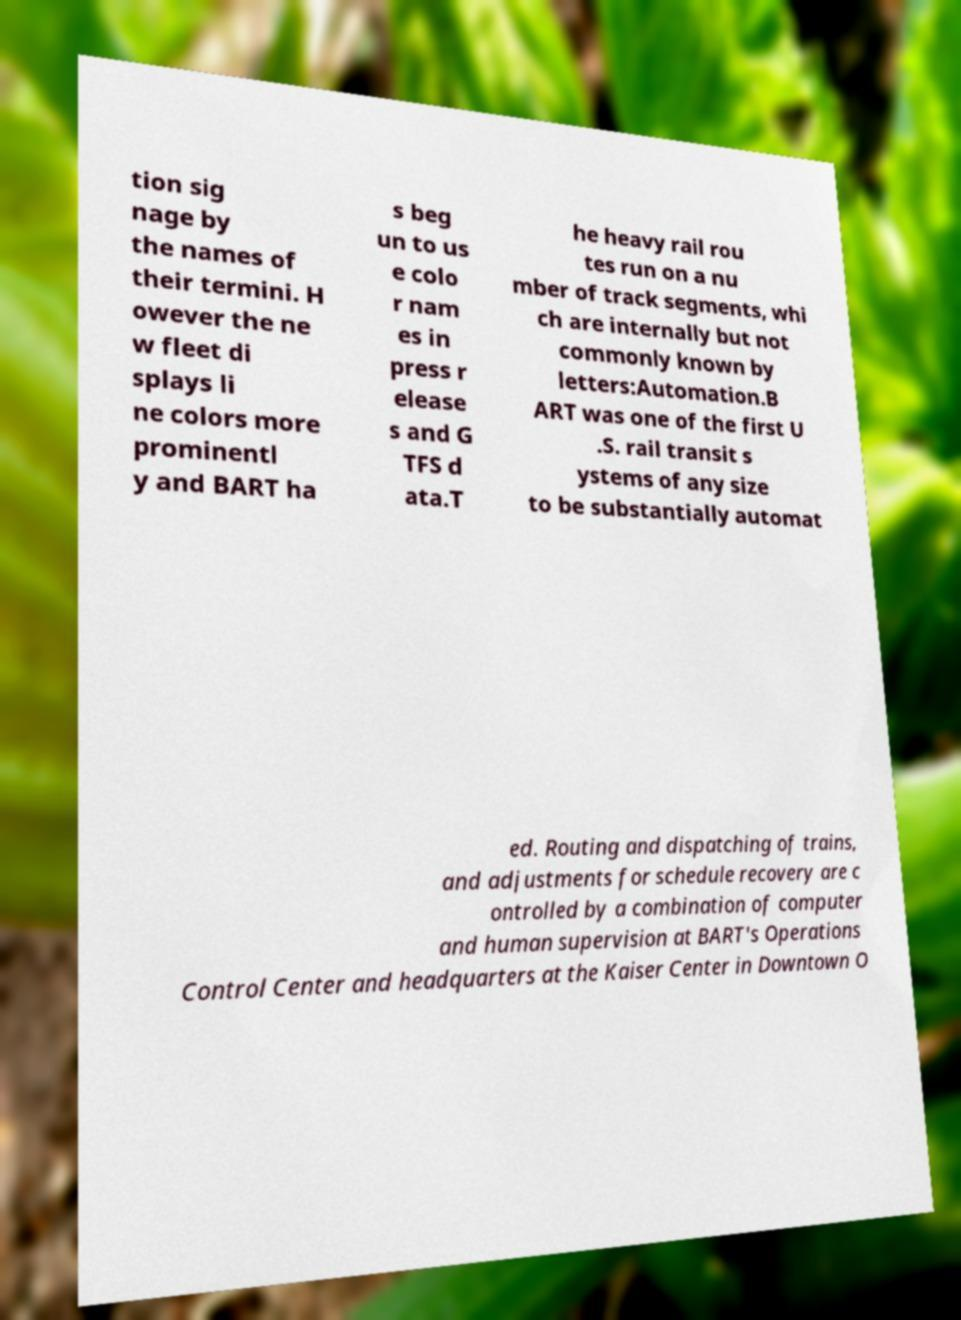Please identify and transcribe the text found in this image. tion sig nage by the names of their termini. H owever the ne w fleet di splays li ne colors more prominentl y and BART ha s beg un to us e colo r nam es in press r elease s and G TFS d ata.T he heavy rail rou tes run on a nu mber of track segments, whi ch are internally but not commonly known by letters:Automation.B ART was one of the first U .S. rail transit s ystems of any size to be substantially automat ed. Routing and dispatching of trains, and adjustments for schedule recovery are c ontrolled by a combination of computer and human supervision at BART's Operations Control Center and headquarters at the Kaiser Center in Downtown O 